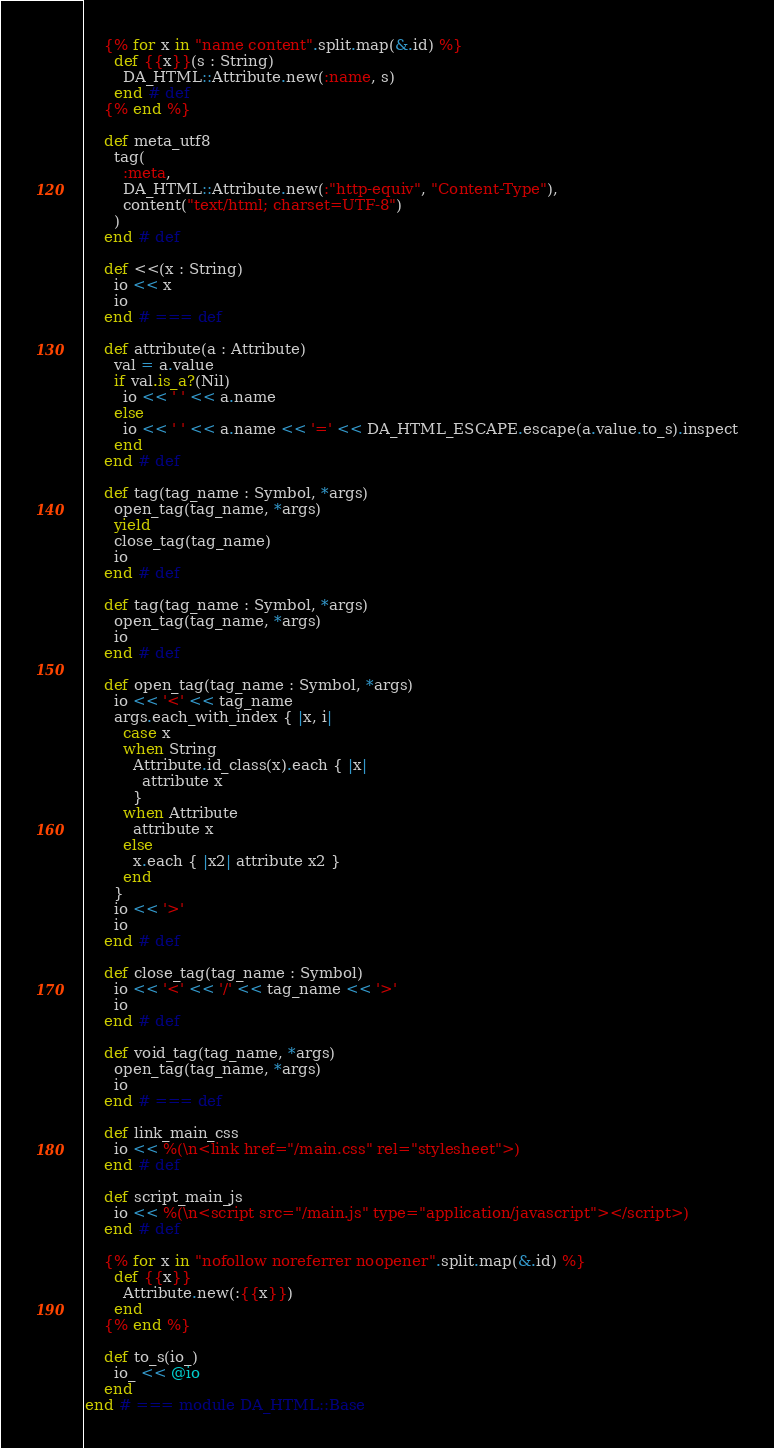<code> <loc_0><loc_0><loc_500><loc_500><_Crystal_>
    {% for x in "name content".split.map(&.id) %}
      def {{x}}(s : String)
        DA_HTML::Attribute.new(:name, s)
      end # def
    {% end %}

    def meta_utf8
      tag(
        :meta,
        DA_HTML::Attribute.new(:"http-equiv", "Content-Type"),
        content("text/html; charset=UTF-8")
      )
    end # def

    def <<(x : String)
      io << x
      io
    end # === def

    def attribute(a : Attribute)
      val = a.value
      if val.is_a?(Nil)
        io << ' ' << a.name
      else
        io << ' ' << a.name << '=' << DA_HTML_ESCAPE.escape(a.value.to_s).inspect
      end
    end # def

    def tag(tag_name : Symbol, *args)
      open_tag(tag_name, *args)
      yield
      close_tag(tag_name)
      io
    end # def

    def tag(tag_name : Symbol, *args)
      open_tag(tag_name, *args)
      io
    end # def

    def open_tag(tag_name : Symbol, *args)
      io << '<' << tag_name
      args.each_with_index { |x, i|
        case x
        when String
          Attribute.id_class(x).each { |x|
            attribute x
          }
        when Attribute
          attribute x
        else
          x.each { |x2| attribute x2 }
        end
      }
      io << '>'
      io
    end # def

    def close_tag(tag_name : Symbol)
      io << '<' << '/' << tag_name << '>'
      io
    end # def

    def void_tag(tag_name, *args)
      open_tag(tag_name, *args)
      io
    end # === def

    def link_main_css
      io << %(\n<link href="/main.css" rel="stylesheet">)
    end # def

    def script_main_js
      io << %(\n<script src="/main.js" type="application/javascript"></script>)
    end # def

    {% for x in "nofollow noreferrer noopener".split.map(&.id) %}
      def {{x}}
        Attribute.new(:{{x}})
      end
    {% end %}

    def to_s(io_)
      io_ << @io
    end
end # === module DA_HTML::Base
</code> 